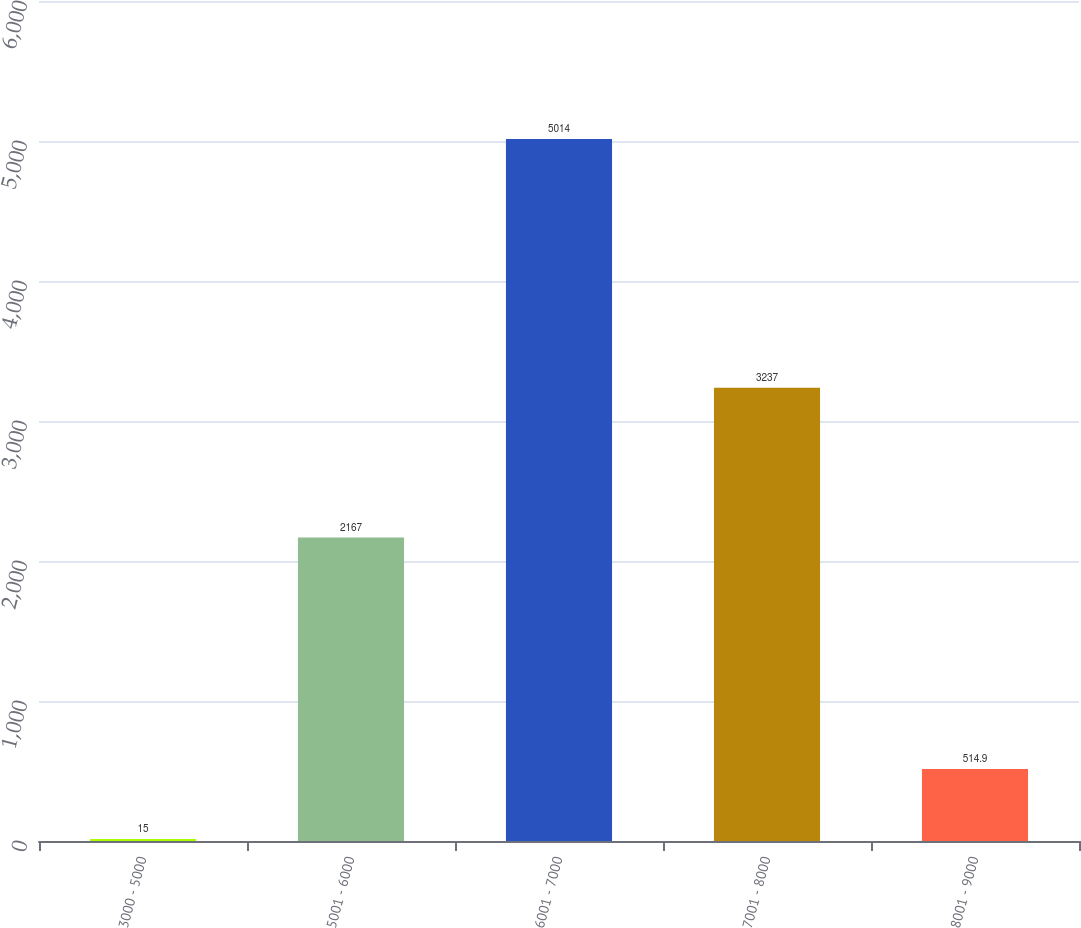<chart> <loc_0><loc_0><loc_500><loc_500><bar_chart><fcel>3000 - 5000<fcel>5001 - 6000<fcel>6001 - 7000<fcel>7001 - 8000<fcel>8001 - 9000<nl><fcel>15<fcel>2167<fcel>5014<fcel>3237<fcel>514.9<nl></chart> 